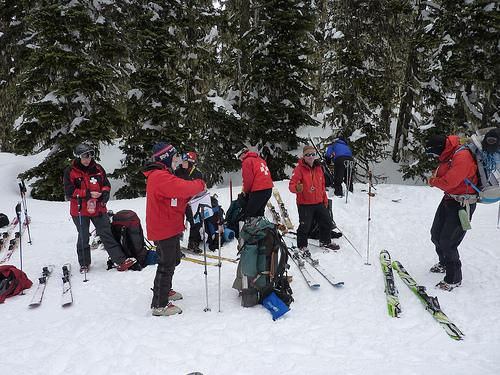Describe the interaction between the objects and the people in the image. People are interacting with ski equipment, such as putting on gloves, wearing ski patrol coats, and having skis and ski poles close by in the snowy environment. What is the woman with the black helmet doing in the image? The woman with the black helmet is putting on her gloves. How many people are depicted wearing red winter coats? There are 4 people wearing red winter coats in the image. What type of equipment can be observed in the image? Ski equipment such as skis, ski poles, and ski patrol coats can be observed in the image. Enumerate the number of people standing in the snow as described by the given image details. There are 5 people standing in the snow in the image. What does the scene in the image mainly consist of? The scene consists of people wearing ski patrol coats, skis, ski poles, and snow-related items in a snowy setting. List down the items that can be found lying on the snow in the image. Items on the snow include skis, ski poles, a red backpack, a large green backpack, and a hatless person in patrol coat. 